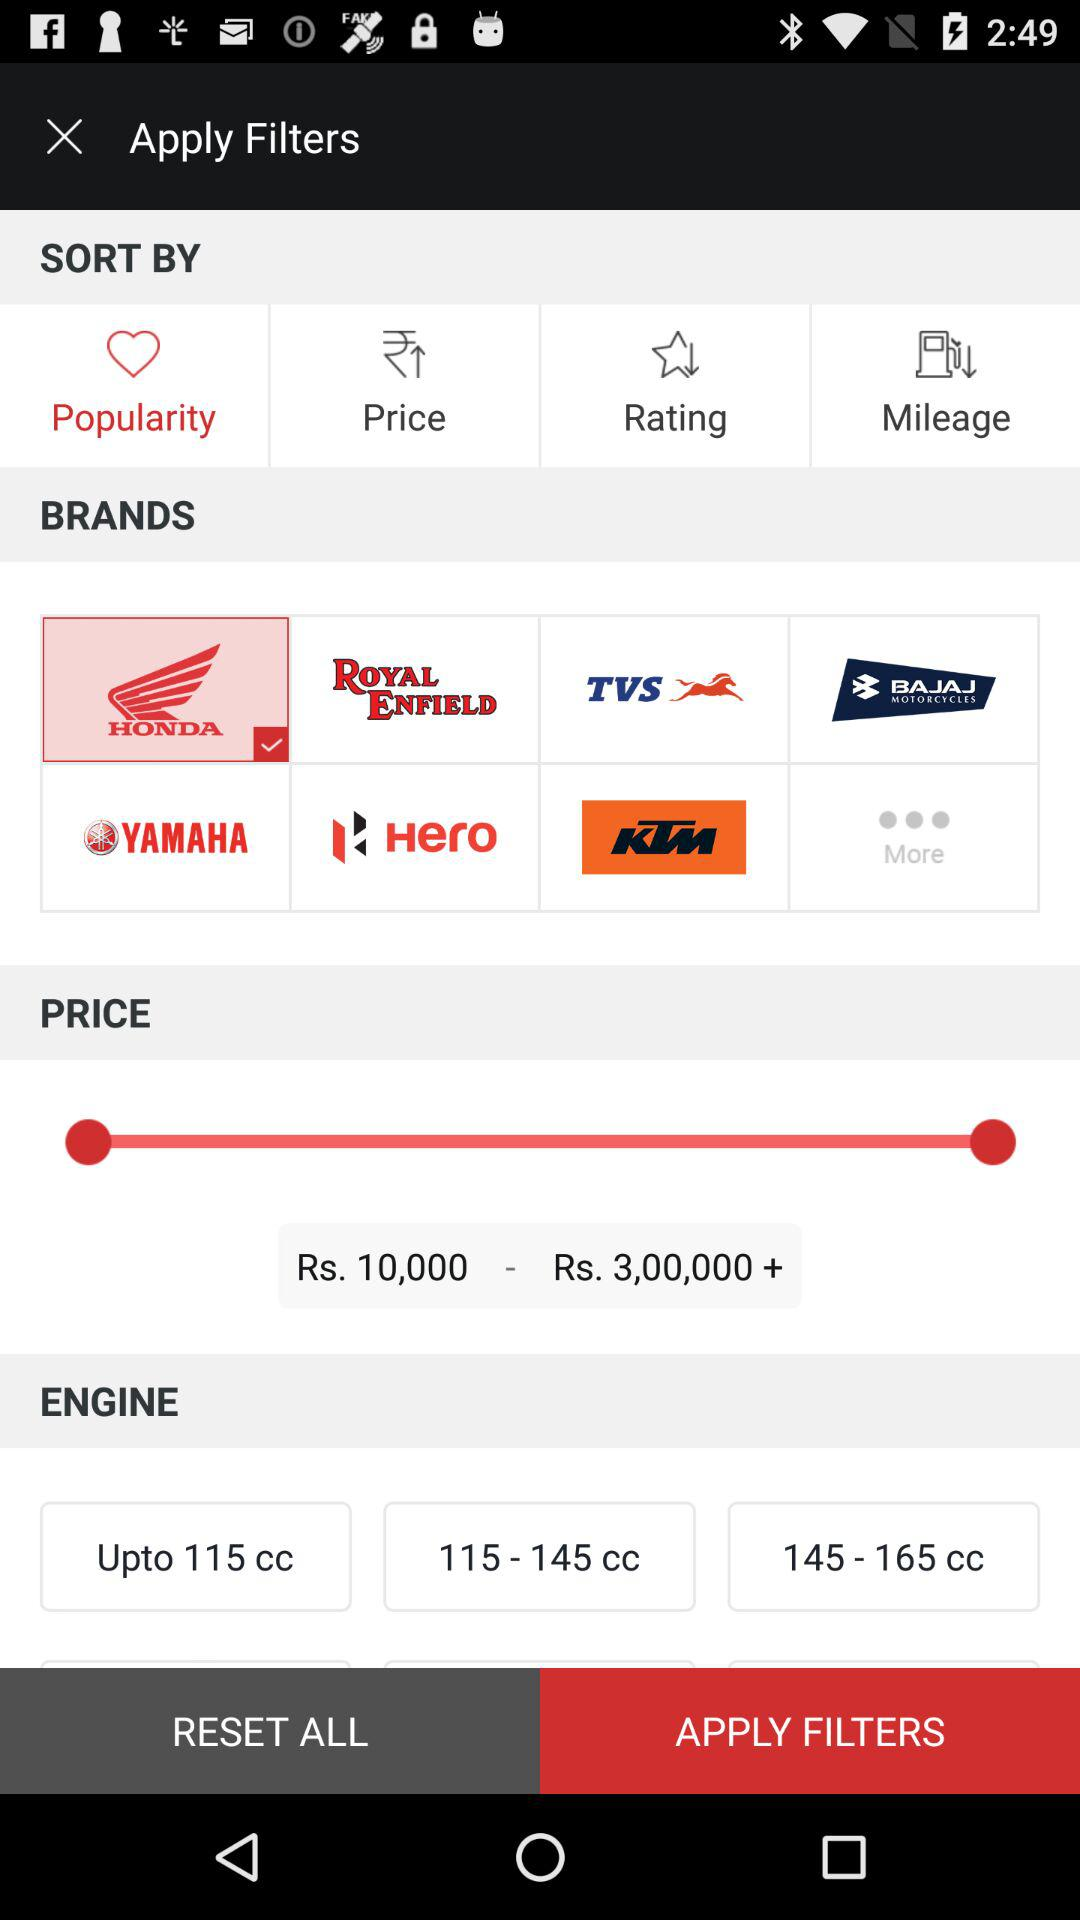How many engine options are available?
Answer the question using a single word or phrase. 3 